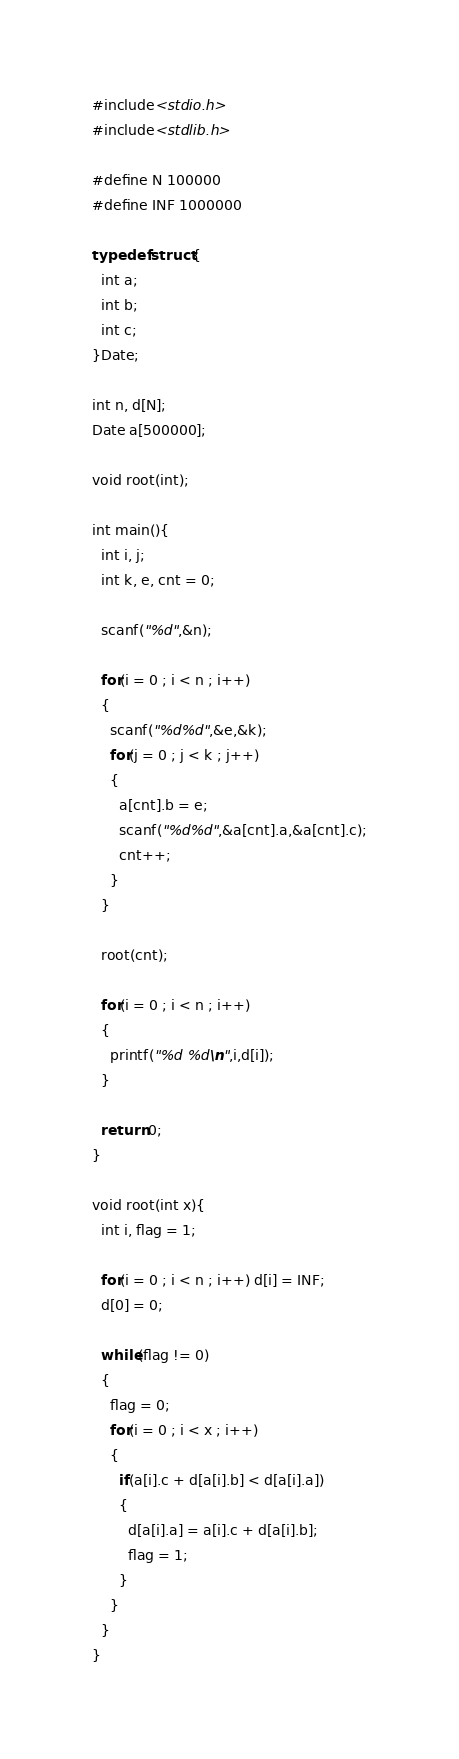<code> <loc_0><loc_0><loc_500><loc_500><_C_>#include<stdio.h>
#include<stdlib.h>

#define N 100000
#define INF 1000000

typedef struct{
  int a; 
  int b; 
  int c; 
}Date;

int n, d[N];
Date a[500000];

void root(int);

int main(){
  int i, j;
  int k, e, cnt = 0;

  scanf("%d",&n);

  for(i = 0 ; i < n ; i++)
  {
    scanf("%d%d",&e,&k);
    for(j = 0 ; j < k ; j++)
    {
      a[cnt].b = e;
      scanf("%d%d",&a[cnt].a,&a[cnt].c);
      cnt++;
    }
  }

  root(cnt);

  for(i = 0 ; i < n ; i++)
  {
    printf("%d %d\n",i,d[i]);
  }

  return 0;
}

void root(int x){
  int i, flag = 1;

  for(i = 0 ; i < n ; i++) d[i] = INF;
  d[0] = 0;

  while(flag != 0)
  {
    flag = 0;
    for(i = 0 ; i < x ; i++)
    {
      if(a[i].c + d[a[i].b] < d[a[i].a])
      {
        d[a[i].a] = a[i].c + d[a[i].b];
        flag = 1;
      }
    }
  }
}


</code> 